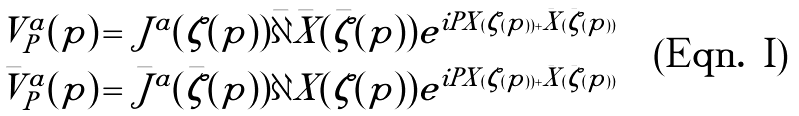<formula> <loc_0><loc_0><loc_500><loc_500>V ^ { a } _ { P } ( p ) \, = \, J ^ { a } ( \zeta ( p ) ) \bar { \partial } \bar { X } ( \bar { \zeta } ( p ) ) e ^ { i P X ( \zeta ( p ) ) + \bar { X } ( \bar { \zeta } ( p ) ) } \\ \bar { V } ^ { a } _ { P } ( p ) \, = \, \bar { J } ^ { a } ( \bar { \zeta } ( p ) ) \partial X ( \zeta ( p ) ) e ^ { i P X ( \zeta ( p ) ) + \bar { X } ( \bar { \zeta } ( p ) ) }</formula> 